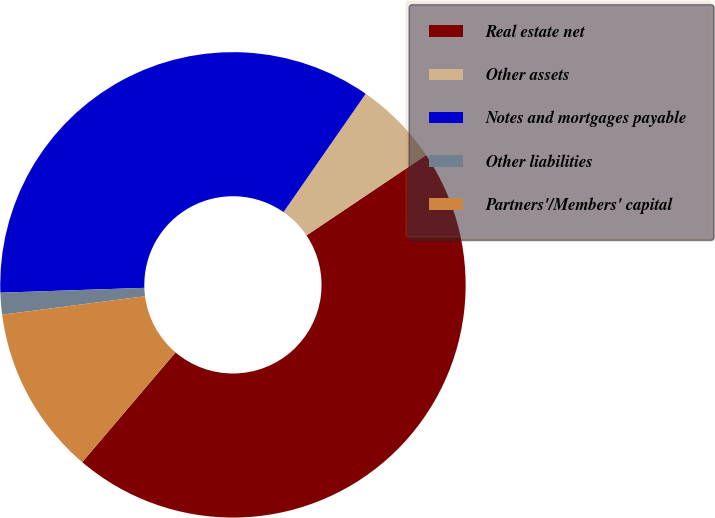Convert chart. <chart><loc_0><loc_0><loc_500><loc_500><pie_chart><fcel>Real estate net<fcel>Other assets<fcel>Notes and mortgages payable<fcel>Other liabilities<fcel>Partners'/Members' capital<nl><fcel>45.63%<fcel>5.92%<fcel>35.2%<fcel>1.51%<fcel>11.74%<nl></chart> 